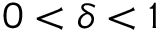<formula> <loc_0><loc_0><loc_500><loc_500>0 < \delta < 1</formula> 